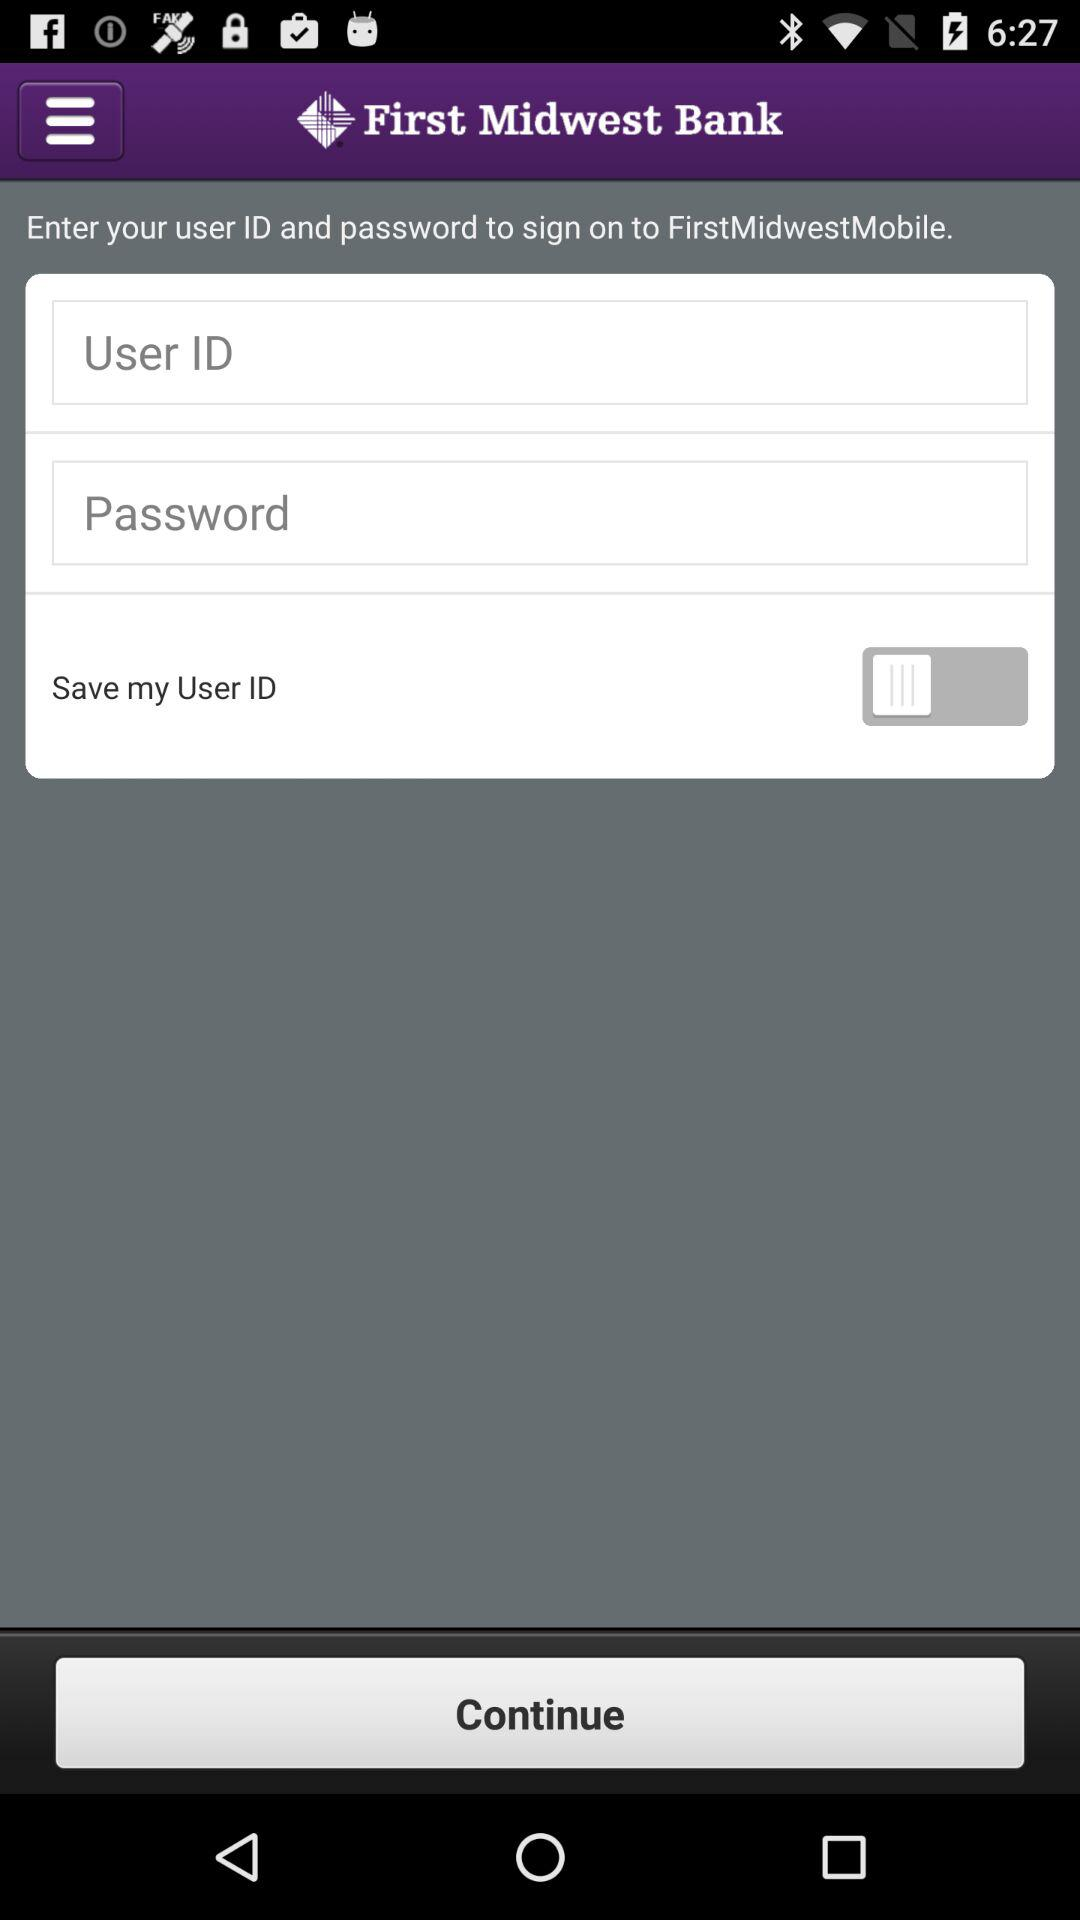What is the user ID?
When the provided information is insufficient, respond with <no answer>. <no answer> 